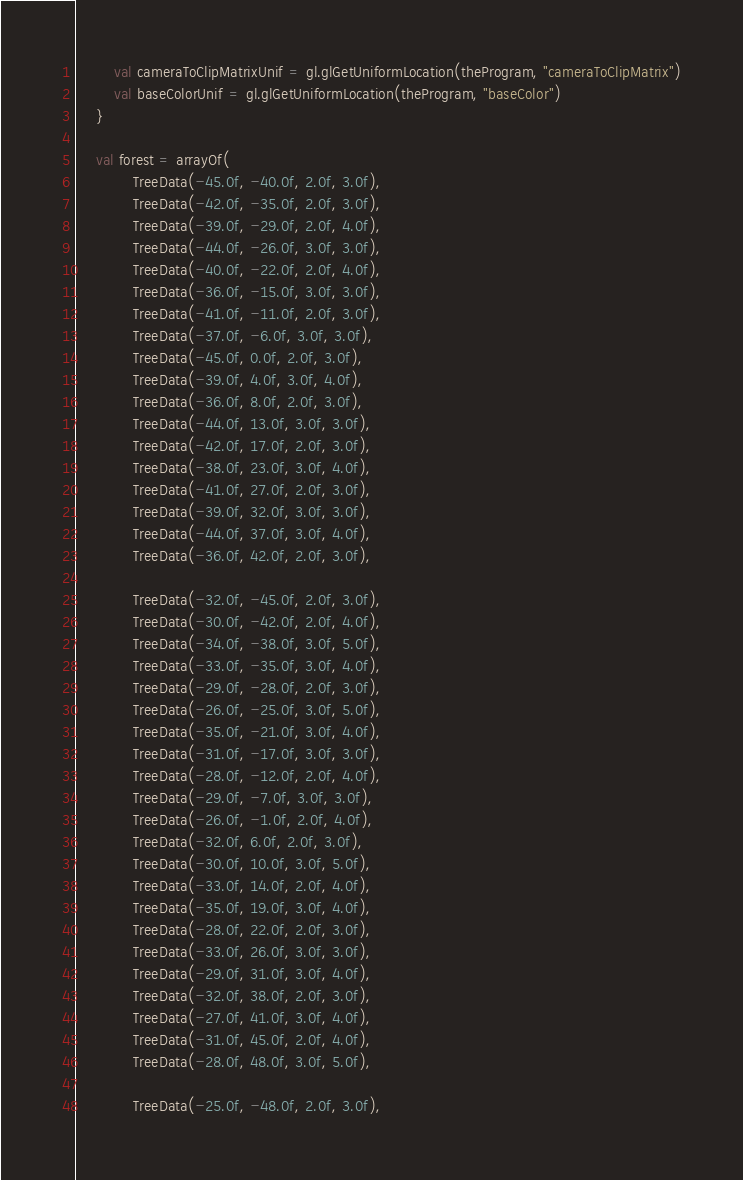Convert code to text. <code><loc_0><loc_0><loc_500><loc_500><_Kotlin_>        val cameraToClipMatrixUnif = gl.glGetUniformLocation(theProgram, "cameraToClipMatrix")
        val baseColorUnif = gl.glGetUniformLocation(theProgram, "baseColor")
    }

    val forest = arrayOf(
            TreeData(-45.0f, -40.0f, 2.0f, 3.0f),
            TreeData(-42.0f, -35.0f, 2.0f, 3.0f),
            TreeData(-39.0f, -29.0f, 2.0f, 4.0f),
            TreeData(-44.0f, -26.0f, 3.0f, 3.0f),
            TreeData(-40.0f, -22.0f, 2.0f, 4.0f),
            TreeData(-36.0f, -15.0f, 3.0f, 3.0f),
            TreeData(-41.0f, -11.0f, 2.0f, 3.0f),
            TreeData(-37.0f, -6.0f, 3.0f, 3.0f),
            TreeData(-45.0f, 0.0f, 2.0f, 3.0f),
            TreeData(-39.0f, 4.0f, 3.0f, 4.0f),
            TreeData(-36.0f, 8.0f, 2.0f, 3.0f),
            TreeData(-44.0f, 13.0f, 3.0f, 3.0f),
            TreeData(-42.0f, 17.0f, 2.0f, 3.0f),
            TreeData(-38.0f, 23.0f, 3.0f, 4.0f),
            TreeData(-41.0f, 27.0f, 2.0f, 3.0f),
            TreeData(-39.0f, 32.0f, 3.0f, 3.0f),
            TreeData(-44.0f, 37.0f, 3.0f, 4.0f),
            TreeData(-36.0f, 42.0f, 2.0f, 3.0f),

            TreeData(-32.0f, -45.0f, 2.0f, 3.0f),
            TreeData(-30.0f, -42.0f, 2.0f, 4.0f),
            TreeData(-34.0f, -38.0f, 3.0f, 5.0f),
            TreeData(-33.0f, -35.0f, 3.0f, 4.0f),
            TreeData(-29.0f, -28.0f, 2.0f, 3.0f),
            TreeData(-26.0f, -25.0f, 3.0f, 5.0f),
            TreeData(-35.0f, -21.0f, 3.0f, 4.0f),
            TreeData(-31.0f, -17.0f, 3.0f, 3.0f),
            TreeData(-28.0f, -12.0f, 2.0f, 4.0f),
            TreeData(-29.0f, -7.0f, 3.0f, 3.0f),
            TreeData(-26.0f, -1.0f, 2.0f, 4.0f),
            TreeData(-32.0f, 6.0f, 2.0f, 3.0f),
            TreeData(-30.0f, 10.0f, 3.0f, 5.0f),
            TreeData(-33.0f, 14.0f, 2.0f, 4.0f),
            TreeData(-35.0f, 19.0f, 3.0f, 4.0f),
            TreeData(-28.0f, 22.0f, 2.0f, 3.0f),
            TreeData(-33.0f, 26.0f, 3.0f, 3.0f),
            TreeData(-29.0f, 31.0f, 3.0f, 4.0f),
            TreeData(-32.0f, 38.0f, 2.0f, 3.0f),
            TreeData(-27.0f, 41.0f, 3.0f, 4.0f),
            TreeData(-31.0f, 45.0f, 2.0f, 4.0f),
            TreeData(-28.0f, 48.0f, 3.0f, 5.0f),

            TreeData(-25.0f, -48.0f, 2.0f, 3.0f),</code> 